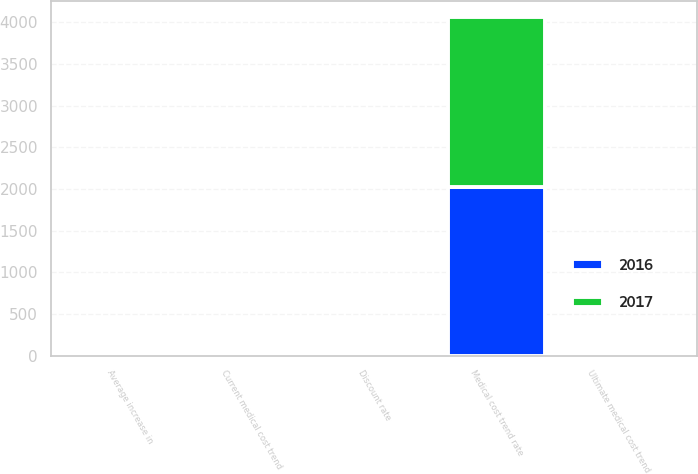<chart> <loc_0><loc_0><loc_500><loc_500><stacked_bar_chart><ecel><fcel>Discount rate<fcel>Average increase in<fcel>Current medical cost trend<fcel>Ultimate medical cost trend<fcel>Medical cost trend rate<nl><fcel>2017<fcel>3.75<fcel>3<fcel>6<fcel>3.5<fcel>2029<nl><fcel>2016<fcel>3.5<fcel>3<fcel>6<fcel>3.5<fcel>2028<nl></chart> 